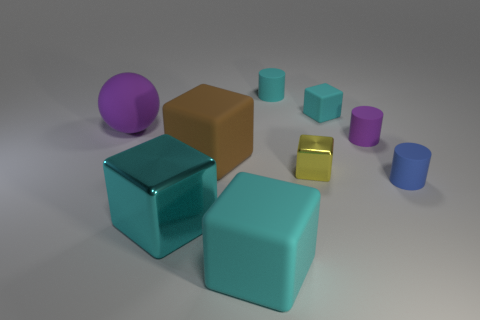Does the cyan object on the right side of the yellow shiny object have the same size as the metallic thing that is behind the tiny blue cylinder?
Make the answer very short. Yes. What is the tiny cyan object to the right of the small cube that is to the left of the small matte block made of?
Your answer should be compact. Rubber. Are there fewer objects that are in front of the big matte sphere than rubber objects?
Provide a short and direct response. Yes. What shape is the big purple thing that is made of the same material as the big brown thing?
Your answer should be very brief. Sphere. How many other things are there of the same shape as the small yellow metallic thing?
Offer a very short reply. 4. What number of brown things are matte cylinders or shiny objects?
Your answer should be compact. 0. Do the tiny purple object and the small blue object have the same shape?
Your response must be concise. Yes. Are there any cylinders behind the big rubber block behind the yellow cube?
Make the answer very short. Yes. Is the number of tiny matte cubes right of the big cyan rubber block the same as the number of big brown metallic balls?
Provide a succinct answer. No. How many other things are there of the same size as the blue thing?
Your answer should be very brief. 4. 